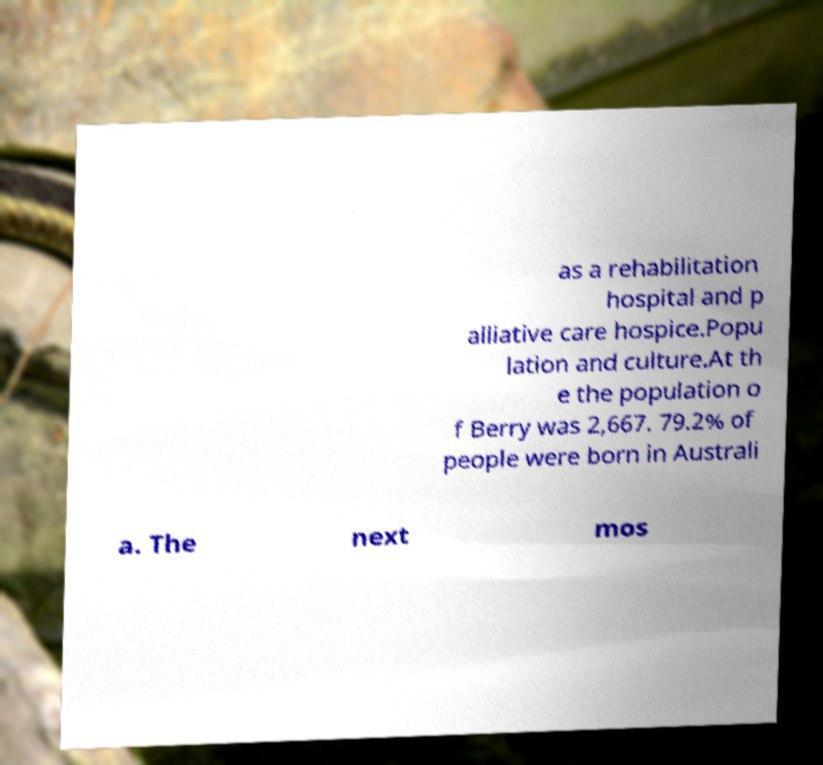Could you extract and type out the text from this image? as a rehabilitation hospital and p alliative care hospice.Popu lation and culture.At th e the population o f Berry was 2,667. 79.2% of people were born in Australi a. The next mos 